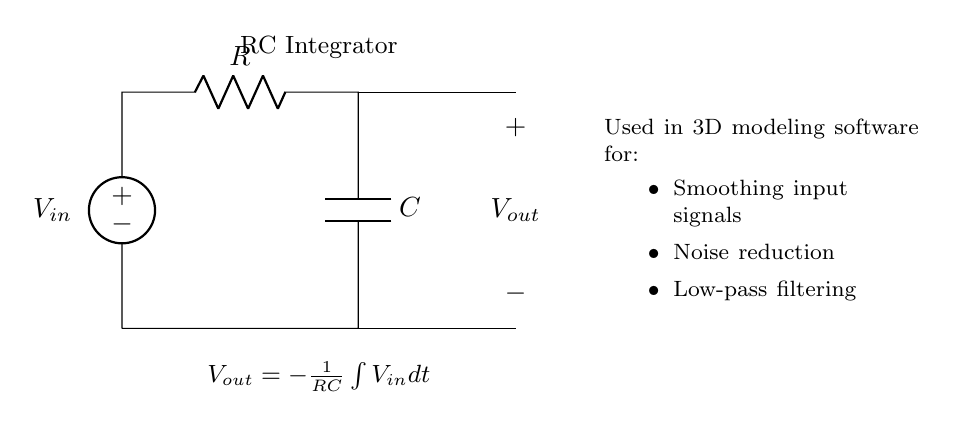What type of circuit is represented? The circuit is an RC integrator, which is indicated by the arrangement of the resistor and capacitor in the diagram. The label at the top of the circuit also confirms it.
Answer: RC integrator What components are in the circuit? The circuit contains a resistor and a capacitor, which can be identified by their symbols in the diagram. Additionally, a voltage source is present.
Answer: Resistor and Capacitor What is the output voltage formula? The formula for output voltage is shown in the circuit diagram as a mathematical expression: Vout = -1/(RC) ∫ Vin dt. This describes the relationship between the output and input voltages in terms of integration.
Answer: Vout = -1/(RC) ∫ Vin dt What is the purpose of this circuit in 3D modeling software? The circuit is used in 3D modeling software for purposes such as smoothing input signals, noise reduction, and low-pass filtering, as listed in the note provided alongside the diagram.
Answer: Smoothing input signals What happens if the resistor value is increased? Increasing the resistor value decreases the output voltage's response time due to the increased time constant (RC), leading to slower integration of the input signal. This increases the filtering effect in the circuit.
Answer: Output voltage response time increases What type of signal does the RC integrator circuit typically process? The RC integrator circuit typically processes analog signals, as indicated by the input voltage, Vin, and the description of its applications in signal processing.
Answer: Analog signals 